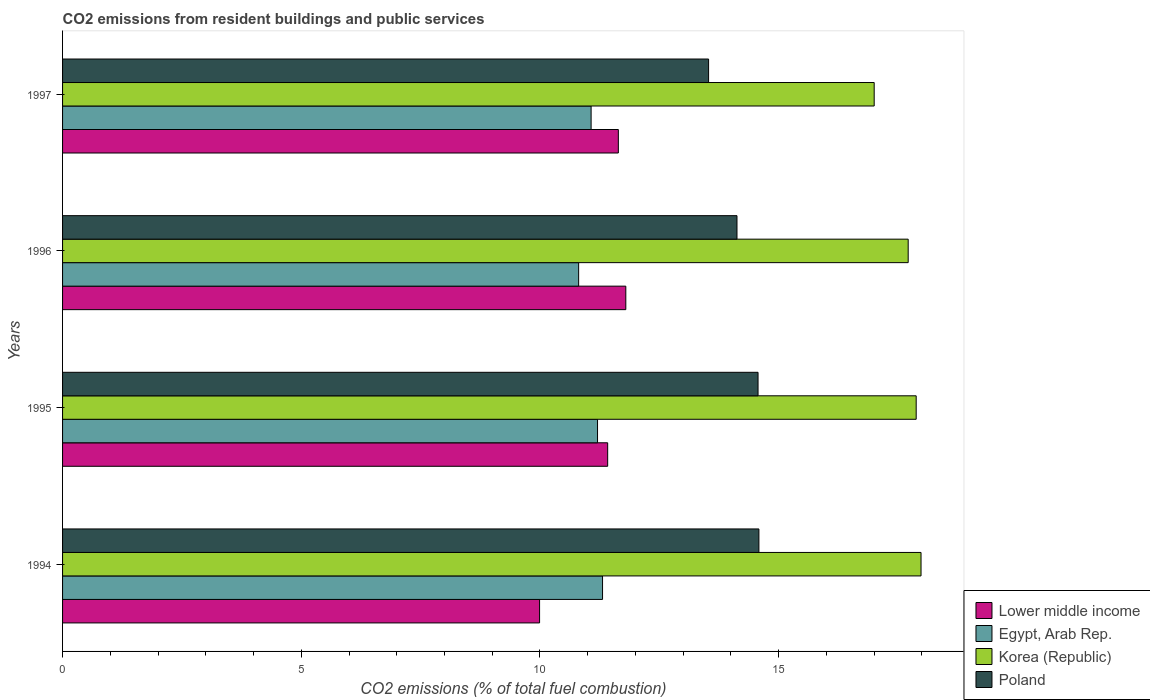How many different coloured bars are there?
Your response must be concise. 4. How many groups of bars are there?
Offer a very short reply. 4. Are the number of bars per tick equal to the number of legend labels?
Give a very brief answer. Yes. How many bars are there on the 1st tick from the top?
Give a very brief answer. 4. In how many cases, is the number of bars for a given year not equal to the number of legend labels?
Provide a short and direct response. 0. What is the total CO2 emitted in Lower middle income in 1996?
Your response must be concise. 11.8. Across all years, what is the maximum total CO2 emitted in Egypt, Arab Rep.?
Offer a terse response. 11.31. Across all years, what is the minimum total CO2 emitted in Egypt, Arab Rep.?
Ensure brevity in your answer.  10.81. In which year was the total CO2 emitted in Poland minimum?
Make the answer very short. 1997. What is the total total CO2 emitted in Egypt, Arab Rep. in the graph?
Make the answer very short. 44.4. What is the difference between the total CO2 emitted in Korea (Republic) in 1994 and that in 1997?
Keep it short and to the point. 0.98. What is the difference between the total CO2 emitted in Korea (Republic) in 1995 and the total CO2 emitted in Egypt, Arab Rep. in 1997?
Offer a very short reply. 6.81. What is the average total CO2 emitted in Egypt, Arab Rep. per year?
Provide a succinct answer. 11.1. In the year 1995, what is the difference between the total CO2 emitted in Korea (Republic) and total CO2 emitted in Egypt, Arab Rep.?
Make the answer very short. 6.67. In how many years, is the total CO2 emitted in Korea (Republic) greater than 16 ?
Your answer should be compact. 4. What is the ratio of the total CO2 emitted in Egypt, Arab Rep. in 1994 to that in 1996?
Your answer should be very brief. 1.05. Is the total CO2 emitted in Egypt, Arab Rep. in 1994 less than that in 1997?
Make the answer very short. No. Is the difference between the total CO2 emitted in Korea (Republic) in 1995 and 1997 greater than the difference between the total CO2 emitted in Egypt, Arab Rep. in 1995 and 1997?
Your answer should be compact. Yes. What is the difference between the highest and the second highest total CO2 emitted in Korea (Republic)?
Provide a short and direct response. 0.1. What is the difference between the highest and the lowest total CO2 emitted in Korea (Republic)?
Provide a short and direct response. 0.98. Is it the case that in every year, the sum of the total CO2 emitted in Poland and total CO2 emitted in Egypt, Arab Rep. is greater than the sum of total CO2 emitted in Korea (Republic) and total CO2 emitted in Lower middle income?
Provide a succinct answer. Yes. What does the 3rd bar from the top in 1995 represents?
Offer a very short reply. Egypt, Arab Rep. What does the 1st bar from the bottom in 1997 represents?
Make the answer very short. Lower middle income. Are all the bars in the graph horizontal?
Give a very brief answer. Yes. Where does the legend appear in the graph?
Your answer should be very brief. Bottom right. How many legend labels are there?
Your response must be concise. 4. How are the legend labels stacked?
Ensure brevity in your answer.  Vertical. What is the title of the graph?
Offer a very short reply. CO2 emissions from resident buildings and public services. Does "Spain" appear as one of the legend labels in the graph?
Make the answer very short. No. What is the label or title of the X-axis?
Provide a short and direct response. CO2 emissions (% of total fuel combustion). What is the label or title of the Y-axis?
Offer a terse response. Years. What is the CO2 emissions (% of total fuel combustion) of Lower middle income in 1994?
Your answer should be very brief. 9.99. What is the CO2 emissions (% of total fuel combustion) in Egypt, Arab Rep. in 1994?
Give a very brief answer. 11.31. What is the CO2 emissions (% of total fuel combustion) of Korea (Republic) in 1994?
Offer a terse response. 17.98. What is the CO2 emissions (% of total fuel combustion) of Poland in 1994?
Offer a terse response. 14.59. What is the CO2 emissions (% of total fuel combustion) in Lower middle income in 1995?
Provide a short and direct response. 11.42. What is the CO2 emissions (% of total fuel combustion) of Egypt, Arab Rep. in 1995?
Your answer should be very brief. 11.21. What is the CO2 emissions (% of total fuel combustion) in Korea (Republic) in 1995?
Provide a short and direct response. 17.88. What is the CO2 emissions (% of total fuel combustion) in Poland in 1995?
Offer a terse response. 14.57. What is the CO2 emissions (% of total fuel combustion) of Lower middle income in 1996?
Offer a terse response. 11.8. What is the CO2 emissions (% of total fuel combustion) in Egypt, Arab Rep. in 1996?
Make the answer very short. 10.81. What is the CO2 emissions (% of total fuel combustion) of Korea (Republic) in 1996?
Your response must be concise. 17.71. What is the CO2 emissions (% of total fuel combustion) in Poland in 1996?
Give a very brief answer. 14.13. What is the CO2 emissions (% of total fuel combustion) in Lower middle income in 1997?
Provide a succinct answer. 11.64. What is the CO2 emissions (% of total fuel combustion) in Egypt, Arab Rep. in 1997?
Provide a succinct answer. 11.07. What is the CO2 emissions (% of total fuel combustion) in Korea (Republic) in 1997?
Provide a short and direct response. 17. What is the CO2 emissions (% of total fuel combustion) in Poland in 1997?
Offer a terse response. 13.53. Across all years, what is the maximum CO2 emissions (% of total fuel combustion) of Lower middle income?
Your response must be concise. 11.8. Across all years, what is the maximum CO2 emissions (% of total fuel combustion) of Egypt, Arab Rep.?
Your answer should be compact. 11.31. Across all years, what is the maximum CO2 emissions (% of total fuel combustion) in Korea (Republic)?
Ensure brevity in your answer.  17.98. Across all years, what is the maximum CO2 emissions (% of total fuel combustion) in Poland?
Make the answer very short. 14.59. Across all years, what is the minimum CO2 emissions (% of total fuel combustion) in Lower middle income?
Provide a succinct answer. 9.99. Across all years, what is the minimum CO2 emissions (% of total fuel combustion) of Egypt, Arab Rep.?
Keep it short and to the point. 10.81. Across all years, what is the minimum CO2 emissions (% of total fuel combustion) in Korea (Republic)?
Provide a short and direct response. 17. Across all years, what is the minimum CO2 emissions (% of total fuel combustion) of Poland?
Keep it short and to the point. 13.53. What is the total CO2 emissions (% of total fuel combustion) in Lower middle income in the graph?
Provide a succinct answer. 44.85. What is the total CO2 emissions (% of total fuel combustion) of Egypt, Arab Rep. in the graph?
Give a very brief answer. 44.4. What is the total CO2 emissions (% of total fuel combustion) of Korea (Republic) in the graph?
Offer a terse response. 70.58. What is the total CO2 emissions (% of total fuel combustion) of Poland in the graph?
Offer a very short reply. 56.81. What is the difference between the CO2 emissions (% of total fuel combustion) of Lower middle income in 1994 and that in 1995?
Ensure brevity in your answer.  -1.43. What is the difference between the CO2 emissions (% of total fuel combustion) in Egypt, Arab Rep. in 1994 and that in 1995?
Offer a very short reply. 0.1. What is the difference between the CO2 emissions (% of total fuel combustion) in Korea (Republic) in 1994 and that in 1995?
Your answer should be compact. 0.1. What is the difference between the CO2 emissions (% of total fuel combustion) of Poland in 1994 and that in 1995?
Your answer should be very brief. 0.02. What is the difference between the CO2 emissions (% of total fuel combustion) of Lower middle income in 1994 and that in 1996?
Keep it short and to the point. -1.81. What is the difference between the CO2 emissions (% of total fuel combustion) of Egypt, Arab Rep. in 1994 and that in 1996?
Your answer should be very brief. 0.5. What is the difference between the CO2 emissions (% of total fuel combustion) in Korea (Republic) in 1994 and that in 1996?
Provide a succinct answer. 0.27. What is the difference between the CO2 emissions (% of total fuel combustion) in Poland in 1994 and that in 1996?
Provide a succinct answer. 0.46. What is the difference between the CO2 emissions (% of total fuel combustion) in Lower middle income in 1994 and that in 1997?
Provide a short and direct response. -1.65. What is the difference between the CO2 emissions (% of total fuel combustion) of Egypt, Arab Rep. in 1994 and that in 1997?
Keep it short and to the point. 0.24. What is the difference between the CO2 emissions (% of total fuel combustion) of Korea (Republic) in 1994 and that in 1997?
Keep it short and to the point. 0.98. What is the difference between the CO2 emissions (% of total fuel combustion) in Poland in 1994 and that in 1997?
Your response must be concise. 1.05. What is the difference between the CO2 emissions (% of total fuel combustion) in Lower middle income in 1995 and that in 1996?
Provide a succinct answer. -0.38. What is the difference between the CO2 emissions (% of total fuel combustion) of Egypt, Arab Rep. in 1995 and that in 1996?
Offer a very short reply. 0.4. What is the difference between the CO2 emissions (% of total fuel combustion) of Korea (Republic) in 1995 and that in 1996?
Your response must be concise. 0.17. What is the difference between the CO2 emissions (% of total fuel combustion) in Poland in 1995 and that in 1996?
Keep it short and to the point. 0.44. What is the difference between the CO2 emissions (% of total fuel combustion) in Lower middle income in 1995 and that in 1997?
Make the answer very short. -0.22. What is the difference between the CO2 emissions (% of total fuel combustion) in Egypt, Arab Rep. in 1995 and that in 1997?
Ensure brevity in your answer.  0.13. What is the difference between the CO2 emissions (% of total fuel combustion) in Korea (Republic) in 1995 and that in 1997?
Provide a succinct answer. 0.88. What is the difference between the CO2 emissions (% of total fuel combustion) in Poland in 1995 and that in 1997?
Offer a terse response. 1.04. What is the difference between the CO2 emissions (% of total fuel combustion) of Lower middle income in 1996 and that in 1997?
Ensure brevity in your answer.  0.16. What is the difference between the CO2 emissions (% of total fuel combustion) of Egypt, Arab Rep. in 1996 and that in 1997?
Your answer should be compact. -0.26. What is the difference between the CO2 emissions (% of total fuel combustion) in Korea (Republic) in 1996 and that in 1997?
Offer a terse response. 0.71. What is the difference between the CO2 emissions (% of total fuel combustion) in Poland in 1996 and that in 1997?
Keep it short and to the point. 0.59. What is the difference between the CO2 emissions (% of total fuel combustion) in Lower middle income in 1994 and the CO2 emissions (% of total fuel combustion) in Egypt, Arab Rep. in 1995?
Your response must be concise. -1.21. What is the difference between the CO2 emissions (% of total fuel combustion) of Lower middle income in 1994 and the CO2 emissions (% of total fuel combustion) of Korea (Republic) in 1995?
Your response must be concise. -7.89. What is the difference between the CO2 emissions (% of total fuel combustion) in Lower middle income in 1994 and the CO2 emissions (% of total fuel combustion) in Poland in 1995?
Offer a very short reply. -4.58. What is the difference between the CO2 emissions (% of total fuel combustion) of Egypt, Arab Rep. in 1994 and the CO2 emissions (% of total fuel combustion) of Korea (Republic) in 1995?
Offer a very short reply. -6.57. What is the difference between the CO2 emissions (% of total fuel combustion) in Egypt, Arab Rep. in 1994 and the CO2 emissions (% of total fuel combustion) in Poland in 1995?
Make the answer very short. -3.26. What is the difference between the CO2 emissions (% of total fuel combustion) in Korea (Republic) in 1994 and the CO2 emissions (% of total fuel combustion) in Poland in 1995?
Offer a very short reply. 3.41. What is the difference between the CO2 emissions (% of total fuel combustion) in Lower middle income in 1994 and the CO2 emissions (% of total fuel combustion) in Egypt, Arab Rep. in 1996?
Your answer should be very brief. -0.82. What is the difference between the CO2 emissions (% of total fuel combustion) of Lower middle income in 1994 and the CO2 emissions (% of total fuel combustion) of Korea (Republic) in 1996?
Ensure brevity in your answer.  -7.72. What is the difference between the CO2 emissions (% of total fuel combustion) in Lower middle income in 1994 and the CO2 emissions (% of total fuel combustion) in Poland in 1996?
Offer a terse response. -4.13. What is the difference between the CO2 emissions (% of total fuel combustion) in Egypt, Arab Rep. in 1994 and the CO2 emissions (% of total fuel combustion) in Korea (Republic) in 1996?
Give a very brief answer. -6.4. What is the difference between the CO2 emissions (% of total fuel combustion) of Egypt, Arab Rep. in 1994 and the CO2 emissions (% of total fuel combustion) of Poland in 1996?
Your answer should be very brief. -2.82. What is the difference between the CO2 emissions (% of total fuel combustion) of Korea (Republic) in 1994 and the CO2 emissions (% of total fuel combustion) of Poland in 1996?
Your answer should be compact. 3.86. What is the difference between the CO2 emissions (% of total fuel combustion) in Lower middle income in 1994 and the CO2 emissions (% of total fuel combustion) in Egypt, Arab Rep. in 1997?
Provide a short and direct response. -1.08. What is the difference between the CO2 emissions (% of total fuel combustion) of Lower middle income in 1994 and the CO2 emissions (% of total fuel combustion) of Korea (Republic) in 1997?
Your response must be concise. -7.01. What is the difference between the CO2 emissions (% of total fuel combustion) in Lower middle income in 1994 and the CO2 emissions (% of total fuel combustion) in Poland in 1997?
Provide a short and direct response. -3.54. What is the difference between the CO2 emissions (% of total fuel combustion) of Egypt, Arab Rep. in 1994 and the CO2 emissions (% of total fuel combustion) of Korea (Republic) in 1997?
Ensure brevity in your answer.  -5.69. What is the difference between the CO2 emissions (% of total fuel combustion) in Egypt, Arab Rep. in 1994 and the CO2 emissions (% of total fuel combustion) in Poland in 1997?
Your answer should be compact. -2.22. What is the difference between the CO2 emissions (% of total fuel combustion) in Korea (Republic) in 1994 and the CO2 emissions (% of total fuel combustion) in Poland in 1997?
Your response must be concise. 4.45. What is the difference between the CO2 emissions (% of total fuel combustion) of Lower middle income in 1995 and the CO2 emissions (% of total fuel combustion) of Egypt, Arab Rep. in 1996?
Offer a terse response. 0.61. What is the difference between the CO2 emissions (% of total fuel combustion) of Lower middle income in 1995 and the CO2 emissions (% of total fuel combustion) of Korea (Republic) in 1996?
Make the answer very short. -6.29. What is the difference between the CO2 emissions (% of total fuel combustion) in Lower middle income in 1995 and the CO2 emissions (% of total fuel combustion) in Poland in 1996?
Give a very brief answer. -2.71. What is the difference between the CO2 emissions (% of total fuel combustion) in Egypt, Arab Rep. in 1995 and the CO2 emissions (% of total fuel combustion) in Korea (Republic) in 1996?
Your response must be concise. -6.51. What is the difference between the CO2 emissions (% of total fuel combustion) in Egypt, Arab Rep. in 1995 and the CO2 emissions (% of total fuel combustion) in Poland in 1996?
Make the answer very short. -2.92. What is the difference between the CO2 emissions (% of total fuel combustion) in Korea (Republic) in 1995 and the CO2 emissions (% of total fuel combustion) in Poland in 1996?
Offer a terse response. 3.75. What is the difference between the CO2 emissions (% of total fuel combustion) in Lower middle income in 1995 and the CO2 emissions (% of total fuel combustion) in Egypt, Arab Rep. in 1997?
Your response must be concise. 0.35. What is the difference between the CO2 emissions (% of total fuel combustion) of Lower middle income in 1995 and the CO2 emissions (% of total fuel combustion) of Korea (Republic) in 1997?
Provide a succinct answer. -5.58. What is the difference between the CO2 emissions (% of total fuel combustion) in Lower middle income in 1995 and the CO2 emissions (% of total fuel combustion) in Poland in 1997?
Give a very brief answer. -2.11. What is the difference between the CO2 emissions (% of total fuel combustion) in Egypt, Arab Rep. in 1995 and the CO2 emissions (% of total fuel combustion) in Korea (Republic) in 1997?
Your answer should be very brief. -5.8. What is the difference between the CO2 emissions (% of total fuel combustion) of Egypt, Arab Rep. in 1995 and the CO2 emissions (% of total fuel combustion) of Poland in 1997?
Your answer should be very brief. -2.33. What is the difference between the CO2 emissions (% of total fuel combustion) of Korea (Republic) in 1995 and the CO2 emissions (% of total fuel combustion) of Poland in 1997?
Your response must be concise. 4.35. What is the difference between the CO2 emissions (% of total fuel combustion) of Lower middle income in 1996 and the CO2 emissions (% of total fuel combustion) of Egypt, Arab Rep. in 1997?
Keep it short and to the point. 0.73. What is the difference between the CO2 emissions (% of total fuel combustion) of Lower middle income in 1996 and the CO2 emissions (% of total fuel combustion) of Korea (Republic) in 1997?
Offer a terse response. -5.2. What is the difference between the CO2 emissions (% of total fuel combustion) of Lower middle income in 1996 and the CO2 emissions (% of total fuel combustion) of Poland in 1997?
Offer a very short reply. -1.73. What is the difference between the CO2 emissions (% of total fuel combustion) of Egypt, Arab Rep. in 1996 and the CO2 emissions (% of total fuel combustion) of Korea (Republic) in 1997?
Your answer should be compact. -6.19. What is the difference between the CO2 emissions (% of total fuel combustion) of Egypt, Arab Rep. in 1996 and the CO2 emissions (% of total fuel combustion) of Poland in 1997?
Provide a short and direct response. -2.72. What is the difference between the CO2 emissions (% of total fuel combustion) of Korea (Republic) in 1996 and the CO2 emissions (% of total fuel combustion) of Poland in 1997?
Provide a short and direct response. 4.18. What is the average CO2 emissions (% of total fuel combustion) in Lower middle income per year?
Your answer should be very brief. 11.21. What is the average CO2 emissions (% of total fuel combustion) of Egypt, Arab Rep. per year?
Your answer should be compact. 11.1. What is the average CO2 emissions (% of total fuel combustion) of Korea (Republic) per year?
Keep it short and to the point. 17.64. What is the average CO2 emissions (% of total fuel combustion) in Poland per year?
Give a very brief answer. 14.2. In the year 1994, what is the difference between the CO2 emissions (% of total fuel combustion) in Lower middle income and CO2 emissions (% of total fuel combustion) in Egypt, Arab Rep.?
Your answer should be compact. -1.32. In the year 1994, what is the difference between the CO2 emissions (% of total fuel combustion) in Lower middle income and CO2 emissions (% of total fuel combustion) in Korea (Republic)?
Your answer should be compact. -7.99. In the year 1994, what is the difference between the CO2 emissions (% of total fuel combustion) in Lower middle income and CO2 emissions (% of total fuel combustion) in Poland?
Provide a short and direct response. -4.59. In the year 1994, what is the difference between the CO2 emissions (% of total fuel combustion) of Egypt, Arab Rep. and CO2 emissions (% of total fuel combustion) of Korea (Republic)?
Keep it short and to the point. -6.67. In the year 1994, what is the difference between the CO2 emissions (% of total fuel combustion) of Egypt, Arab Rep. and CO2 emissions (% of total fuel combustion) of Poland?
Your answer should be very brief. -3.28. In the year 1994, what is the difference between the CO2 emissions (% of total fuel combustion) in Korea (Republic) and CO2 emissions (% of total fuel combustion) in Poland?
Your answer should be very brief. 3.4. In the year 1995, what is the difference between the CO2 emissions (% of total fuel combustion) of Lower middle income and CO2 emissions (% of total fuel combustion) of Egypt, Arab Rep.?
Provide a succinct answer. 0.21. In the year 1995, what is the difference between the CO2 emissions (% of total fuel combustion) of Lower middle income and CO2 emissions (% of total fuel combustion) of Korea (Republic)?
Your answer should be compact. -6.46. In the year 1995, what is the difference between the CO2 emissions (% of total fuel combustion) in Lower middle income and CO2 emissions (% of total fuel combustion) in Poland?
Keep it short and to the point. -3.15. In the year 1995, what is the difference between the CO2 emissions (% of total fuel combustion) of Egypt, Arab Rep. and CO2 emissions (% of total fuel combustion) of Korea (Republic)?
Ensure brevity in your answer.  -6.67. In the year 1995, what is the difference between the CO2 emissions (% of total fuel combustion) in Egypt, Arab Rep. and CO2 emissions (% of total fuel combustion) in Poland?
Offer a terse response. -3.36. In the year 1995, what is the difference between the CO2 emissions (% of total fuel combustion) in Korea (Republic) and CO2 emissions (% of total fuel combustion) in Poland?
Offer a very short reply. 3.31. In the year 1996, what is the difference between the CO2 emissions (% of total fuel combustion) of Lower middle income and CO2 emissions (% of total fuel combustion) of Egypt, Arab Rep.?
Give a very brief answer. 0.99. In the year 1996, what is the difference between the CO2 emissions (% of total fuel combustion) in Lower middle income and CO2 emissions (% of total fuel combustion) in Korea (Republic)?
Ensure brevity in your answer.  -5.91. In the year 1996, what is the difference between the CO2 emissions (% of total fuel combustion) of Lower middle income and CO2 emissions (% of total fuel combustion) of Poland?
Offer a terse response. -2.33. In the year 1996, what is the difference between the CO2 emissions (% of total fuel combustion) of Egypt, Arab Rep. and CO2 emissions (% of total fuel combustion) of Korea (Republic)?
Ensure brevity in your answer.  -6.9. In the year 1996, what is the difference between the CO2 emissions (% of total fuel combustion) in Egypt, Arab Rep. and CO2 emissions (% of total fuel combustion) in Poland?
Provide a succinct answer. -3.32. In the year 1996, what is the difference between the CO2 emissions (% of total fuel combustion) of Korea (Republic) and CO2 emissions (% of total fuel combustion) of Poland?
Your response must be concise. 3.59. In the year 1997, what is the difference between the CO2 emissions (% of total fuel combustion) of Lower middle income and CO2 emissions (% of total fuel combustion) of Egypt, Arab Rep.?
Keep it short and to the point. 0.57. In the year 1997, what is the difference between the CO2 emissions (% of total fuel combustion) of Lower middle income and CO2 emissions (% of total fuel combustion) of Korea (Republic)?
Provide a short and direct response. -5.36. In the year 1997, what is the difference between the CO2 emissions (% of total fuel combustion) of Lower middle income and CO2 emissions (% of total fuel combustion) of Poland?
Provide a succinct answer. -1.89. In the year 1997, what is the difference between the CO2 emissions (% of total fuel combustion) in Egypt, Arab Rep. and CO2 emissions (% of total fuel combustion) in Korea (Republic)?
Keep it short and to the point. -5.93. In the year 1997, what is the difference between the CO2 emissions (% of total fuel combustion) of Egypt, Arab Rep. and CO2 emissions (% of total fuel combustion) of Poland?
Make the answer very short. -2.46. In the year 1997, what is the difference between the CO2 emissions (% of total fuel combustion) in Korea (Republic) and CO2 emissions (% of total fuel combustion) in Poland?
Provide a succinct answer. 3.47. What is the ratio of the CO2 emissions (% of total fuel combustion) in Lower middle income in 1994 to that in 1995?
Offer a terse response. 0.88. What is the ratio of the CO2 emissions (% of total fuel combustion) of Egypt, Arab Rep. in 1994 to that in 1995?
Your answer should be compact. 1.01. What is the ratio of the CO2 emissions (% of total fuel combustion) of Korea (Republic) in 1994 to that in 1995?
Make the answer very short. 1.01. What is the ratio of the CO2 emissions (% of total fuel combustion) in Poland in 1994 to that in 1995?
Your response must be concise. 1. What is the ratio of the CO2 emissions (% of total fuel combustion) of Lower middle income in 1994 to that in 1996?
Offer a very short reply. 0.85. What is the ratio of the CO2 emissions (% of total fuel combustion) of Egypt, Arab Rep. in 1994 to that in 1996?
Make the answer very short. 1.05. What is the ratio of the CO2 emissions (% of total fuel combustion) in Korea (Republic) in 1994 to that in 1996?
Your response must be concise. 1.02. What is the ratio of the CO2 emissions (% of total fuel combustion) of Poland in 1994 to that in 1996?
Your response must be concise. 1.03. What is the ratio of the CO2 emissions (% of total fuel combustion) in Lower middle income in 1994 to that in 1997?
Your answer should be compact. 0.86. What is the ratio of the CO2 emissions (% of total fuel combustion) in Egypt, Arab Rep. in 1994 to that in 1997?
Your answer should be very brief. 1.02. What is the ratio of the CO2 emissions (% of total fuel combustion) of Korea (Republic) in 1994 to that in 1997?
Provide a short and direct response. 1.06. What is the ratio of the CO2 emissions (% of total fuel combustion) in Poland in 1994 to that in 1997?
Keep it short and to the point. 1.08. What is the ratio of the CO2 emissions (% of total fuel combustion) in Lower middle income in 1995 to that in 1996?
Provide a short and direct response. 0.97. What is the ratio of the CO2 emissions (% of total fuel combustion) in Egypt, Arab Rep. in 1995 to that in 1996?
Offer a terse response. 1.04. What is the ratio of the CO2 emissions (% of total fuel combustion) of Korea (Republic) in 1995 to that in 1996?
Provide a succinct answer. 1.01. What is the ratio of the CO2 emissions (% of total fuel combustion) in Poland in 1995 to that in 1996?
Offer a very short reply. 1.03. What is the ratio of the CO2 emissions (% of total fuel combustion) of Lower middle income in 1995 to that in 1997?
Offer a terse response. 0.98. What is the ratio of the CO2 emissions (% of total fuel combustion) in Egypt, Arab Rep. in 1995 to that in 1997?
Your response must be concise. 1.01. What is the ratio of the CO2 emissions (% of total fuel combustion) of Korea (Republic) in 1995 to that in 1997?
Keep it short and to the point. 1.05. What is the ratio of the CO2 emissions (% of total fuel combustion) of Poland in 1995 to that in 1997?
Give a very brief answer. 1.08. What is the ratio of the CO2 emissions (% of total fuel combustion) of Lower middle income in 1996 to that in 1997?
Offer a terse response. 1.01. What is the ratio of the CO2 emissions (% of total fuel combustion) in Egypt, Arab Rep. in 1996 to that in 1997?
Your response must be concise. 0.98. What is the ratio of the CO2 emissions (% of total fuel combustion) of Korea (Republic) in 1996 to that in 1997?
Offer a terse response. 1.04. What is the ratio of the CO2 emissions (% of total fuel combustion) of Poland in 1996 to that in 1997?
Give a very brief answer. 1.04. What is the difference between the highest and the second highest CO2 emissions (% of total fuel combustion) in Lower middle income?
Offer a very short reply. 0.16. What is the difference between the highest and the second highest CO2 emissions (% of total fuel combustion) in Egypt, Arab Rep.?
Keep it short and to the point. 0.1. What is the difference between the highest and the second highest CO2 emissions (% of total fuel combustion) of Korea (Republic)?
Ensure brevity in your answer.  0.1. What is the difference between the highest and the second highest CO2 emissions (% of total fuel combustion) of Poland?
Keep it short and to the point. 0.02. What is the difference between the highest and the lowest CO2 emissions (% of total fuel combustion) of Lower middle income?
Ensure brevity in your answer.  1.81. What is the difference between the highest and the lowest CO2 emissions (% of total fuel combustion) of Egypt, Arab Rep.?
Give a very brief answer. 0.5. What is the difference between the highest and the lowest CO2 emissions (% of total fuel combustion) in Korea (Republic)?
Keep it short and to the point. 0.98. What is the difference between the highest and the lowest CO2 emissions (% of total fuel combustion) of Poland?
Make the answer very short. 1.05. 